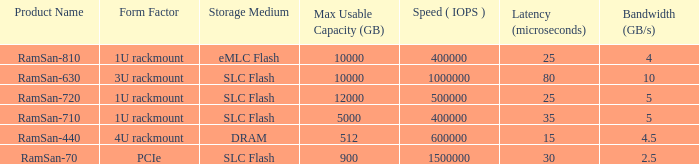What is the Input/output operations per second for the emlc flash? 400000.0. 